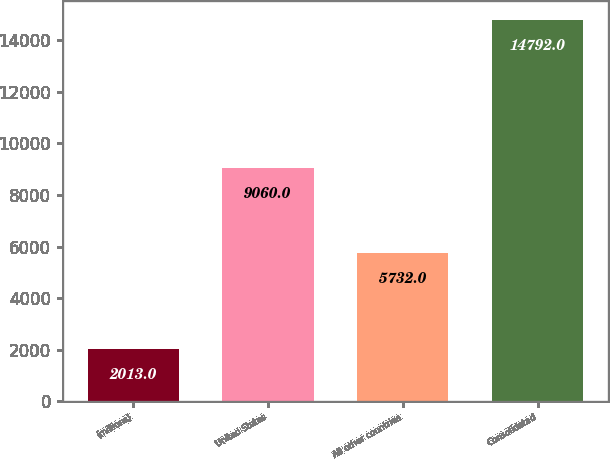Convert chart to OTSL. <chart><loc_0><loc_0><loc_500><loc_500><bar_chart><fcel>(millions)<fcel>United States<fcel>All other countries<fcel>Consolidated<nl><fcel>2013<fcel>9060<fcel>5732<fcel>14792<nl></chart> 